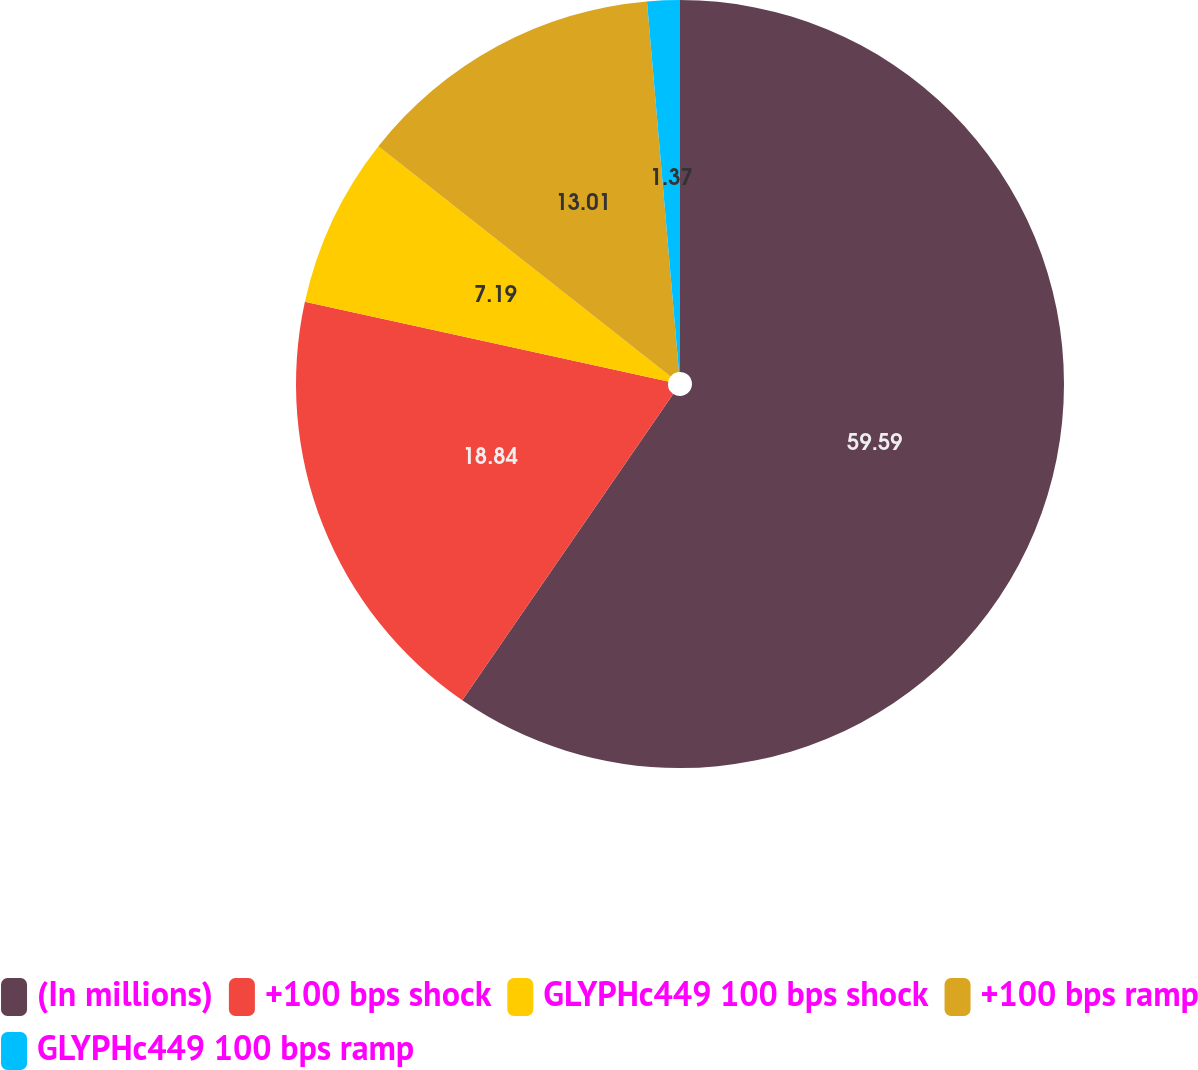<chart> <loc_0><loc_0><loc_500><loc_500><pie_chart><fcel>(In millions)<fcel>+100 bps shock<fcel>GLYPHc449 100 bps shock<fcel>+100 bps ramp<fcel>GLYPHc449 100 bps ramp<nl><fcel>59.6%<fcel>18.84%<fcel>7.19%<fcel>13.01%<fcel>1.37%<nl></chart> 